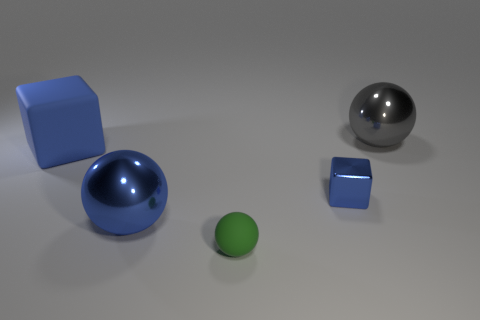Add 5 blue metallic cubes. How many objects exist? 10 Subtract all blocks. How many objects are left? 3 Add 4 blue metallic things. How many blue metallic things are left? 6 Add 2 small gray metal objects. How many small gray metal objects exist? 2 Subtract 0 blue cylinders. How many objects are left? 5 Subtract all large gray balls. Subtract all shiny blocks. How many objects are left? 3 